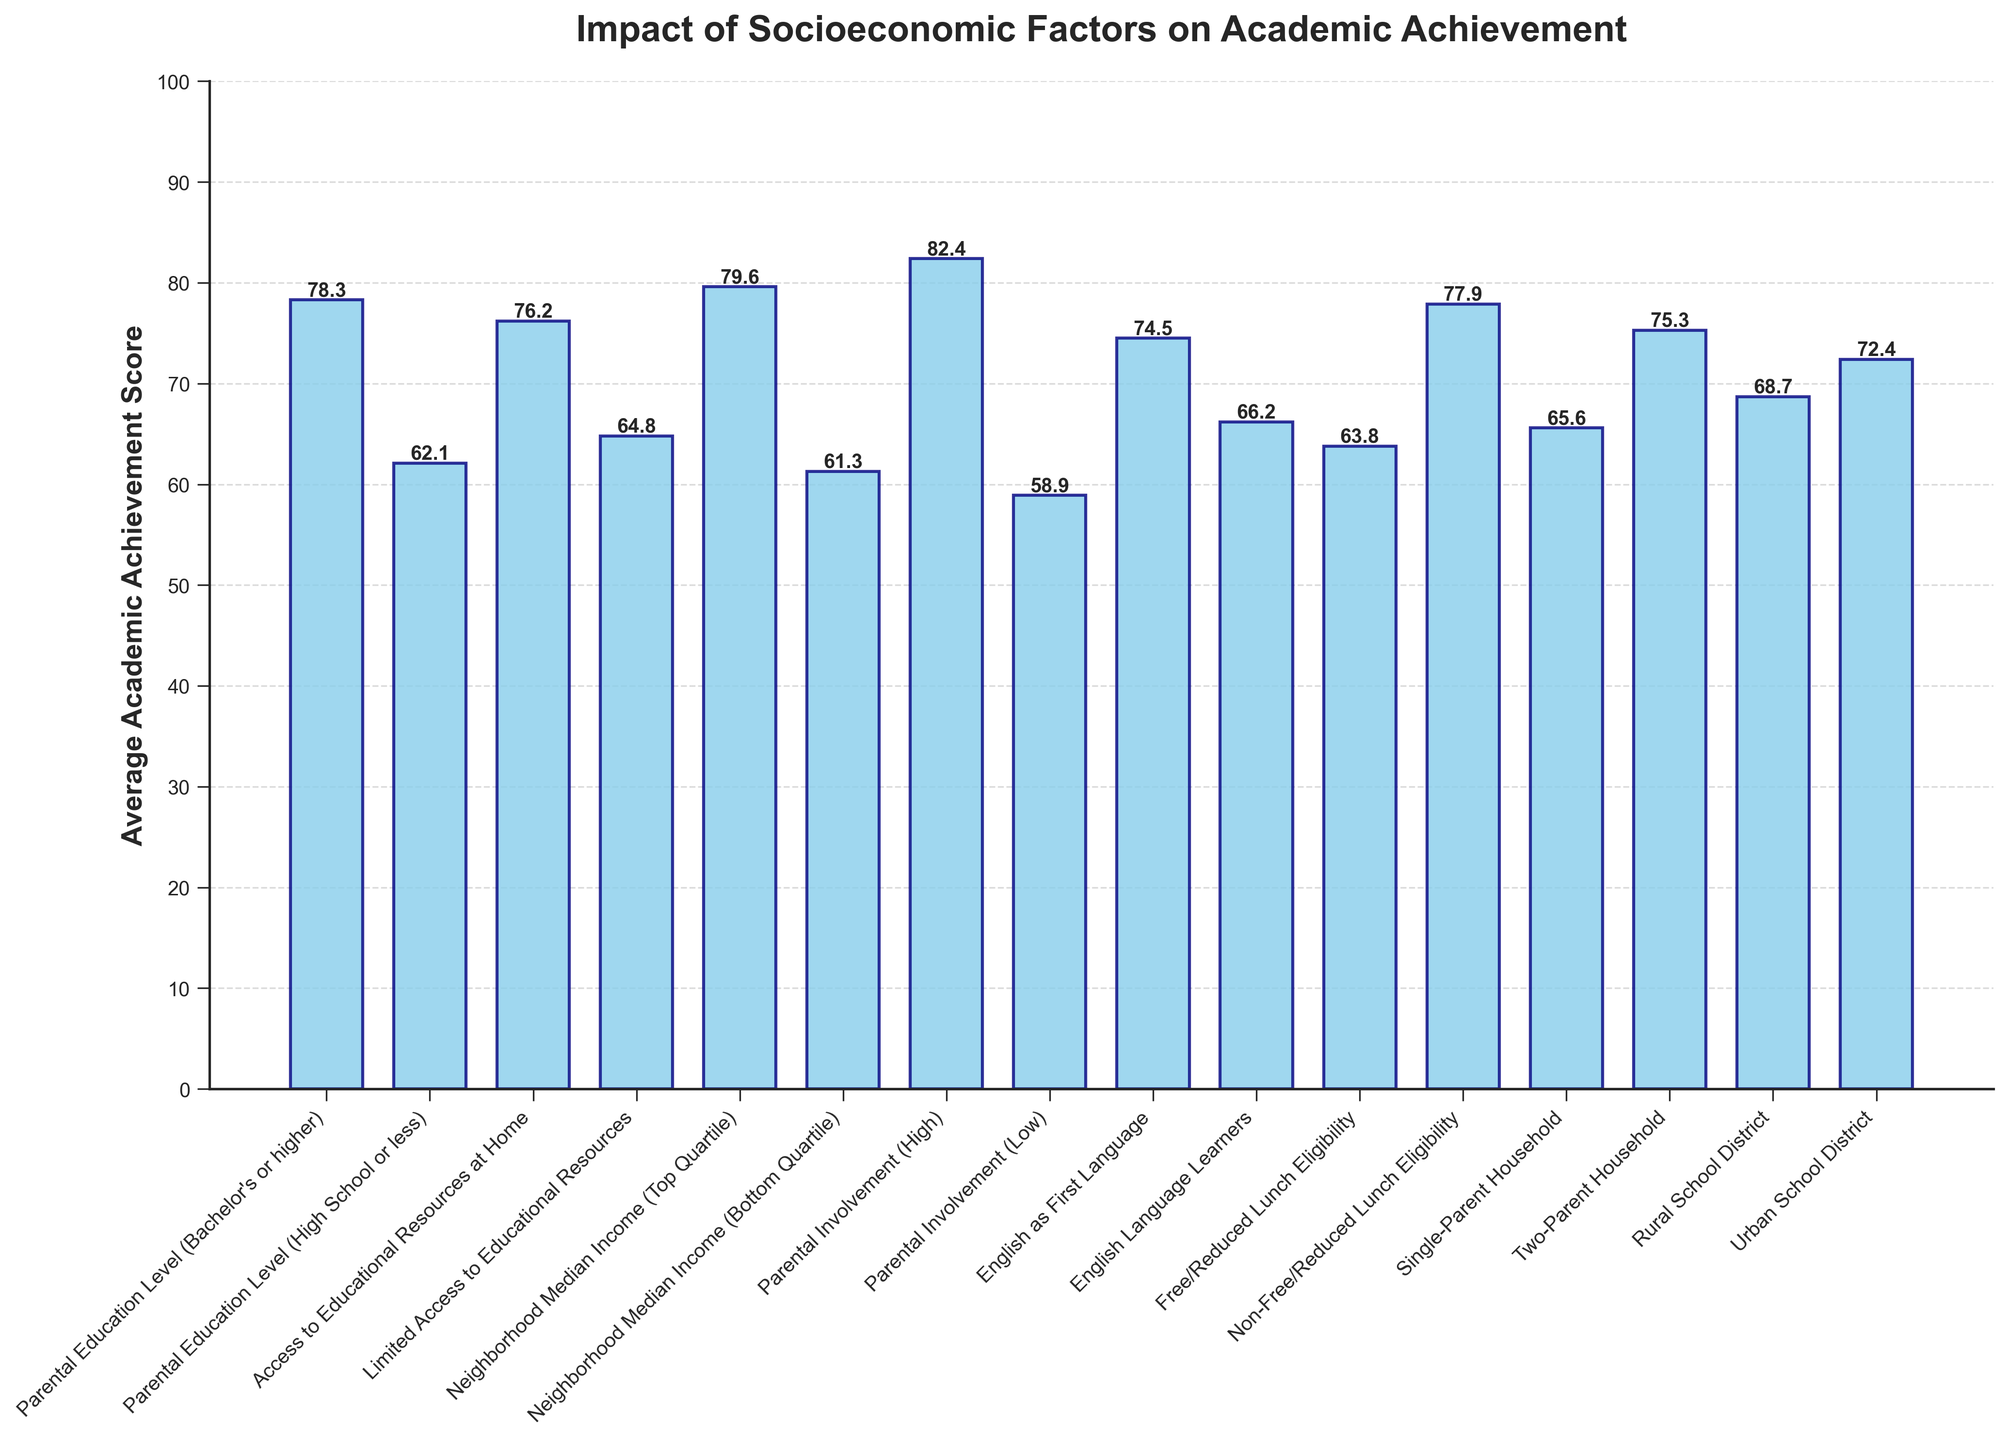Which socioeconomic factor has the highest average academic achievement score? The highest average academic achievement score is represented by the tallest bar on the chart. "Parental Involvement (High)" has the highest value at 82.4.
Answer: Parental Involvement (High) Between "Parental Education Level (Bachelor's or higher)" and "Limited Access to Educational Resources", which has a higher average academic achievement score? By how much? To compare the two, check their respective bars. "Parental Education Level (Bachelor's or higher)" has an average score of 78.3, and "Limited Access to Educational Resources" has 64.8. The difference is 78.3 - 64.8 = 13.5.
Answer: Parental Education Level (Bachelor's or higher) by 13.5 What is the average difference in academic achievement scores between "Rural School District" and "Urban School District"? From the chart, "Rural School District" has a score of 68.7, and "Urban School District" has 72.4. The difference is 72.4 - 68.7 = 3.7.
Answer: 3.7 How do "English as First Language" and "English Language Learners" compare in terms of academic achievement scores? Look at the chart for the heights of these bars. "English as First Language" has a score of 74.5, while "English Language Learners" has 66.2. Thus, "English as First Language" has a higher score by 74.5 - 66.2 = 8.3.
Answer: "English as First Language" by 8.3 Which factor has a lower academic achievement score: "Single-Parent Household" or "Free/Reduced Lunch Eligibility"? Identify their respective bars. "Single-Parent Household" has a score of 65.6, and "Free/Reduced Lunch Eligibility" has 63.8. Therefore, "Free/Reduced Lunch Eligibility" has a lower score.
Answer: Free/Reduced Lunch Eligibility What is the score range between the lowest and highest average academic achievement scores in the figure? The highest value is 82.4 (Parental Involvement - High) and the lowest is 58.9 (Parental Involvement - Low). The range is 82.4 - 58.9 = 23.5.
Answer: 23.5 By how much does the average academic achievement score increase from "Non-Free/Reduced Lunch Eligibility" to "Parental Involvement (High)"? Referring to the chart, "Non-Free/Reduced Lunch Eligibility" has a score of 77.9, and "Parental Involvement (High)" has 82.4. The increase is 82.4 - 77.9 = 4.5.
Answer: 4.5 What is the total average academic achievement score when summing all categories? Sum all the average scores from each category directly from the chart: 78.3 + 62.1 + 76.2 + 64.8 + 79.6 + 61.3 + 82.4 + 58.9 + 74.5 + 66.2 + 63.8 + 77.9 + 65.6 + 75.3 + 68.7 + 72.4 = 1127.
Answer: 1127 